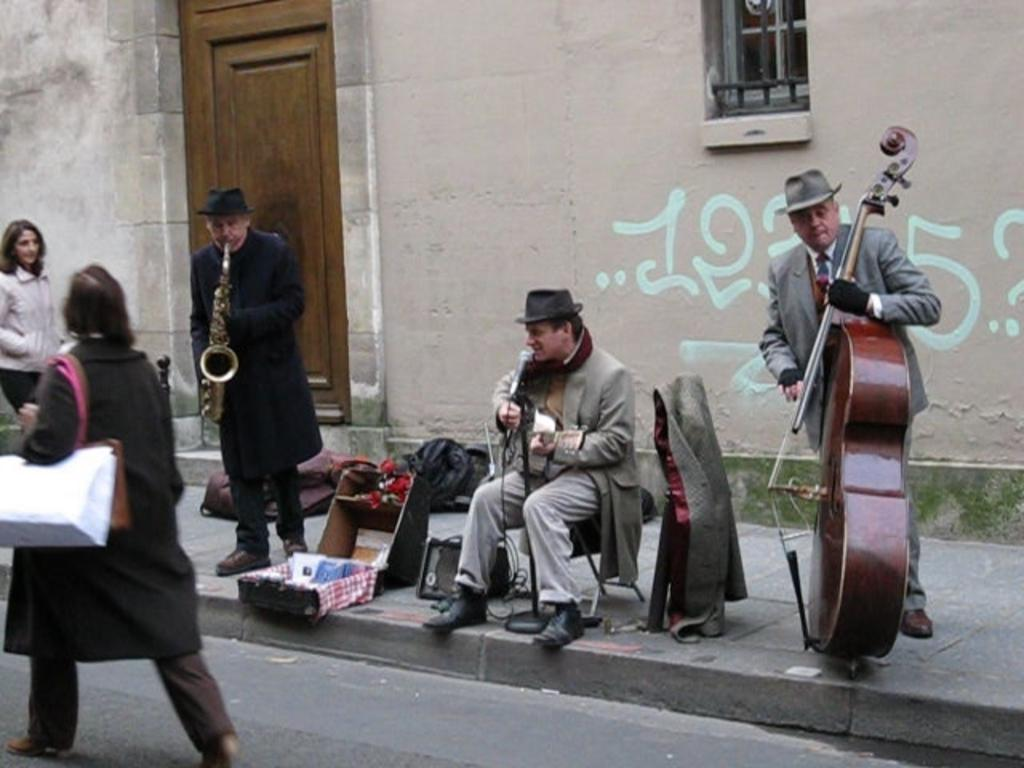What are the persons on the road doing in the image? Some of the persons on the road are holding musical instruments. What can be seen in the background of the image? Walls, windows, and a door are visible in the background of the image. What type of plant is growing inside the door in the image? There is no plant growing inside the door in the image; the door is visible in the background, but there is no indication of a plant. 